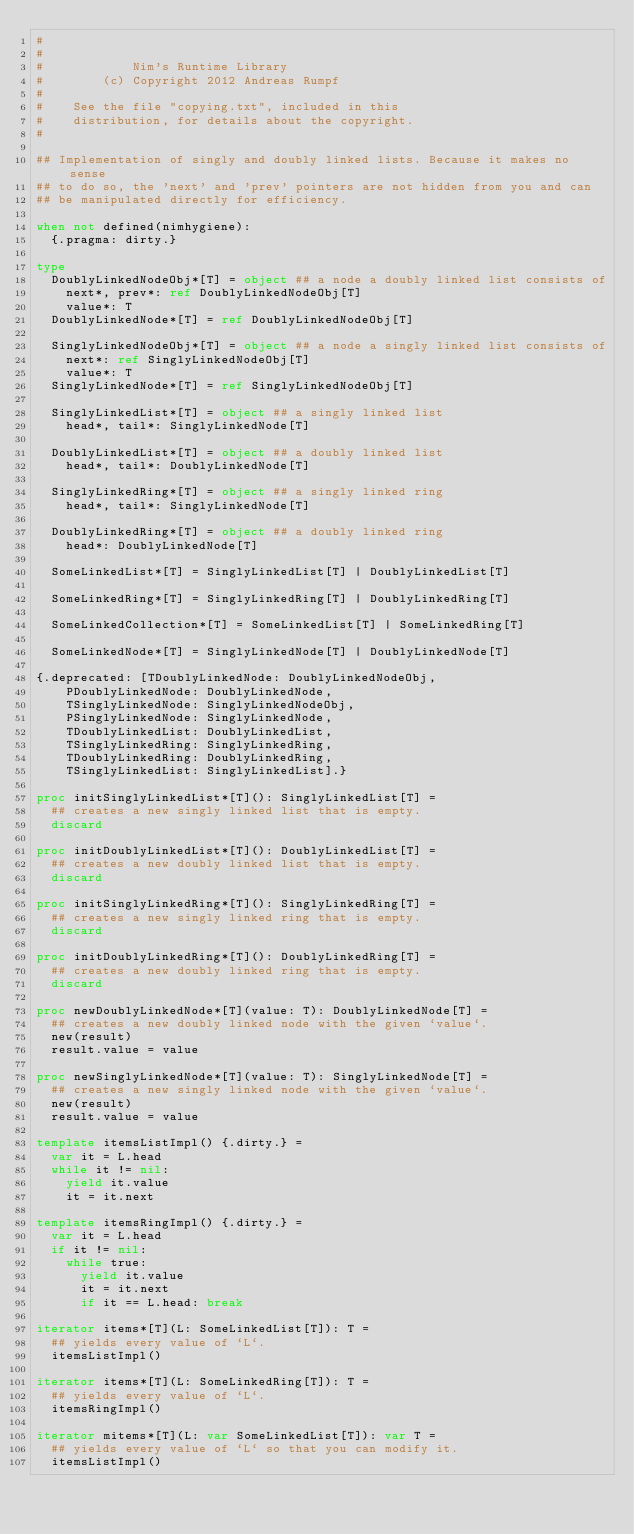<code> <loc_0><loc_0><loc_500><loc_500><_Nim_>#
#
#            Nim's Runtime Library
#        (c) Copyright 2012 Andreas Rumpf
#
#    See the file "copying.txt", included in this
#    distribution, for details about the copyright.
#

## Implementation of singly and doubly linked lists. Because it makes no sense
## to do so, the 'next' and 'prev' pointers are not hidden from you and can
## be manipulated directly for efficiency.

when not defined(nimhygiene):
  {.pragma: dirty.}

type
  DoublyLinkedNodeObj*[T] = object ## a node a doubly linked list consists of
    next*, prev*: ref DoublyLinkedNodeObj[T]
    value*: T
  DoublyLinkedNode*[T] = ref DoublyLinkedNodeObj[T]

  SinglyLinkedNodeObj*[T] = object ## a node a singly linked list consists of
    next*: ref SinglyLinkedNodeObj[T]
    value*: T
  SinglyLinkedNode*[T] = ref SinglyLinkedNodeObj[T]

  SinglyLinkedList*[T] = object ## a singly linked list
    head*, tail*: SinglyLinkedNode[T]

  DoublyLinkedList*[T] = object ## a doubly linked list
    head*, tail*: DoublyLinkedNode[T]

  SinglyLinkedRing*[T] = object ## a singly linked ring
    head*, tail*: SinglyLinkedNode[T]

  DoublyLinkedRing*[T] = object ## a doubly linked ring
    head*: DoublyLinkedNode[T]

  SomeLinkedList*[T] = SinglyLinkedList[T] | DoublyLinkedList[T]

  SomeLinkedRing*[T] = SinglyLinkedRing[T] | DoublyLinkedRing[T]

  SomeLinkedCollection*[T] = SomeLinkedList[T] | SomeLinkedRing[T]

  SomeLinkedNode*[T] = SinglyLinkedNode[T] | DoublyLinkedNode[T]

{.deprecated: [TDoublyLinkedNode: DoublyLinkedNodeObj,
    PDoublyLinkedNode: DoublyLinkedNode,
    TSinglyLinkedNode: SinglyLinkedNodeObj,
    PSinglyLinkedNode: SinglyLinkedNode,
    TDoublyLinkedList: DoublyLinkedList,
    TSinglyLinkedRing: SinglyLinkedRing,
    TDoublyLinkedRing: DoublyLinkedRing,
    TSinglyLinkedList: SinglyLinkedList].}

proc initSinglyLinkedList*[T](): SinglyLinkedList[T] =
  ## creates a new singly linked list that is empty.
  discard

proc initDoublyLinkedList*[T](): DoublyLinkedList[T] =
  ## creates a new doubly linked list that is empty.
  discard

proc initSinglyLinkedRing*[T](): SinglyLinkedRing[T] =
  ## creates a new singly linked ring that is empty.
  discard

proc initDoublyLinkedRing*[T](): DoublyLinkedRing[T] =
  ## creates a new doubly linked ring that is empty.
  discard

proc newDoublyLinkedNode*[T](value: T): DoublyLinkedNode[T] =
  ## creates a new doubly linked node with the given `value`.
  new(result)
  result.value = value

proc newSinglyLinkedNode*[T](value: T): SinglyLinkedNode[T] =
  ## creates a new singly linked node with the given `value`.
  new(result)
  result.value = value

template itemsListImpl() {.dirty.} =
  var it = L.head
  while it != nil:
    yield it.value
    it = it.next

template itemsRingImpl() {.dirty.} =
  var it = L.head
  if it != nil:
    while true:
      yield it.value
      it = it.next
      if it == L.head: break

iterator items*[T](L: SomeLinkedList[T]): T =
  ## yields every value of `L`.
  itemsListImpl()

iterator items*[T](L: SomeLinkedRing[T]): T =
  ## yields every value of `L`.
  itemsRingImpl()

iterator mitems*[T](L: var SomeLinkedList[T]): var T =
  ## yields every value of `L` so that you can modify it.
  itemsListImpl()
</code> 